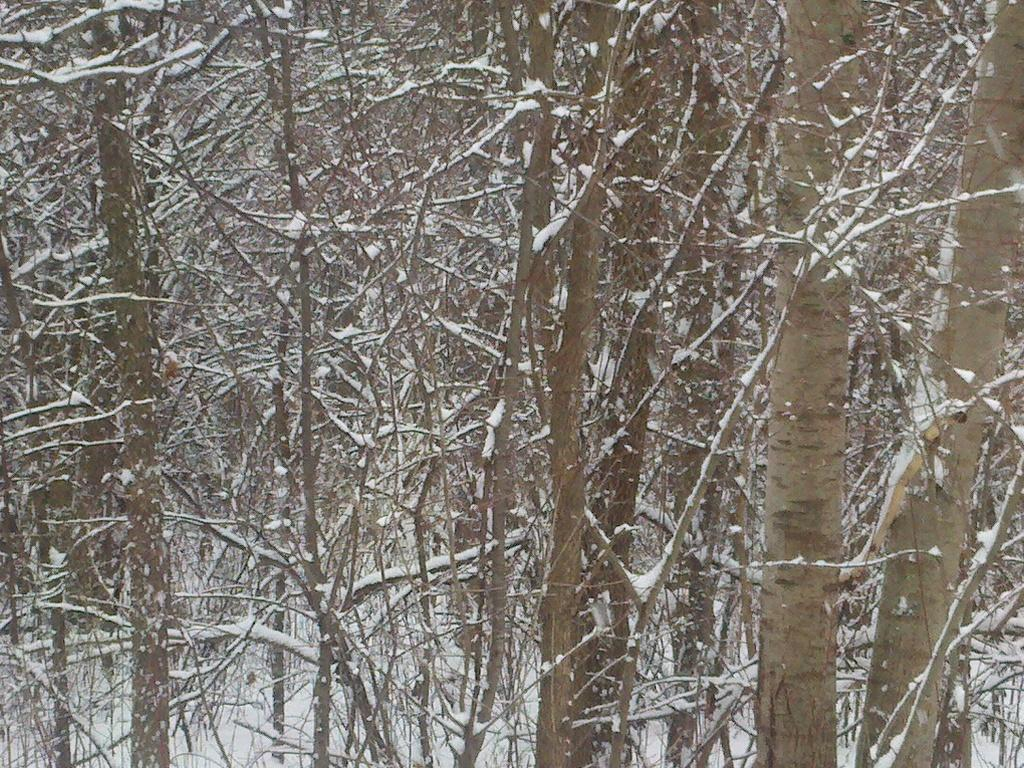Where was the image taken? The image was taken outdoors. What can be seen in the background of the image? There are many trees in the image. What is covering the ground in the image? The ground is covered with snow. What type of riddle can be seen written on the trees in the image? There are no riddles written on the trees in the image; it features trees and snow-covered ground. 